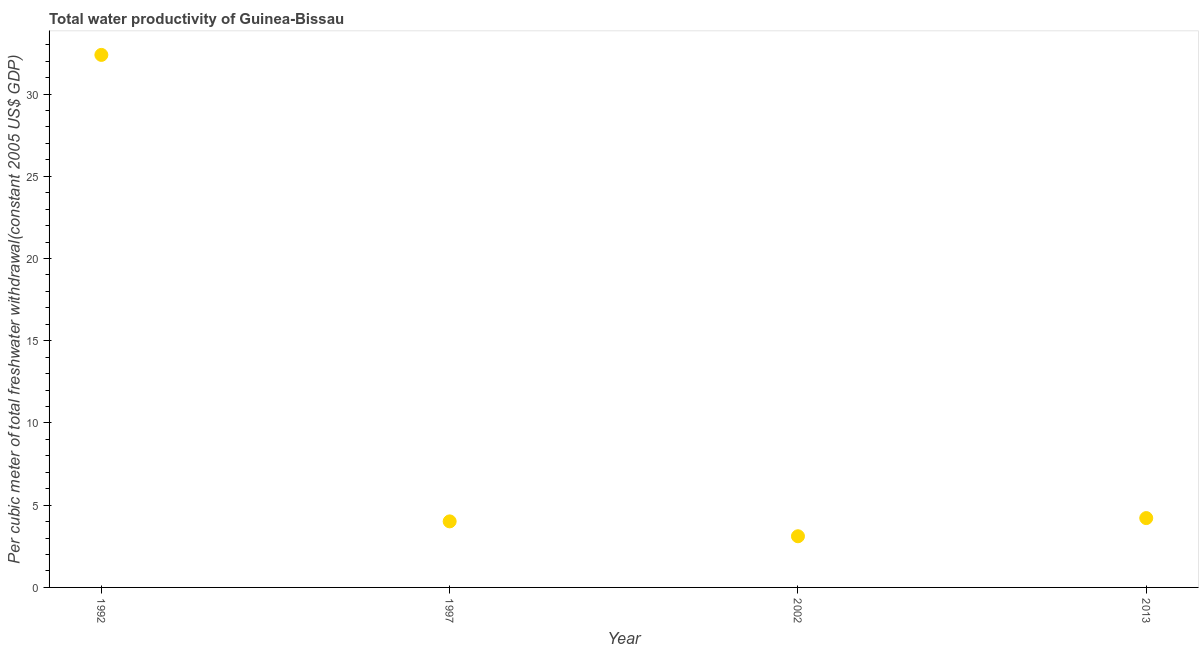What is the total water productivity in 2002?
Give a very brief answer. 3.11. Across all years, what is the maximum total water productivity?
Give a very brief answer. 32.38. Across all years, what is the minimum total water productivity?
Offer a very short reply. 3.11. In which year was the total water productivity minimum?
Give a very brief answer. 2002. What is the sum of the total water productivity?
Give a very brief answer. 43.73. What is the difference between the total water productivity in 2002 and 2013?
Keep it short and to the point. -1.1. What is the average total water productivity per year?
Your answer should be very brief. 10.93. What is the median total water productivity?
Make the answer very short. 4.12. Do a majority of the years between 1992 and 2002 (inclusive) have total water productivity greater than 9 US$?
Provide a succinct answer. No. What is the ratio of the total water productivity in 1997 to that in 2013?
Offer a very short reply. 0.95. Is the total water productivity in 2002 less than that in 2013?
Your response must be concise. Yes. What is the difference between the highest and the second highest total water productivity?
Your answer should be very brief. 28.17. What is the difference between the highest and the lowest total water productivity?
Keep it short and to the point. 29.27. Are the values on the major ticks of Y-axis written in scientific E-notation?
Make the answer very short. No. Does the graph contain any zero values?
Your response must be concise. No. What is the title of the graph?
Ensure brevity in your answer.  Total water productivity of Guinea-Bissau. What is the label or title of the X-axis?
Keep it short and to the point. Year. What is the label or title of the Y-axis?
Offer a very short reply. Per cubic meter of total freshwater withdrawal(constant 2005 US$ GDP). What is the Per cubic meter of total freshwater withdrawal(constant 2005 US$ GDP) in 1992?
Your answer should be very brief. 32.38. What is the Per cubic meter of total freshwater withdrawal(constant 2005 US$ GDP) in 1997?
Keep it short and to the point. 4.02. What is the Per cubic meter of total freshwater withdrawal(constant 2005 US$ GDP) in 2002?
Offer a terse response. 3.11. What is the Per cubic meter of total freshwater withdrawal(constant 2005 US$ GDP) in 2013?
Your answer should be very brief. 4.22. What is the difference between the Per cubic meter of total freshwater withdrawal(constant 2005 US$ GDP) in 1992 and 1997?
Ensure brevity in your answer.  28.37. What is the difference between the Per cubic meter of total freshwater withdrawal(constant 2005 US$ GDP) in 1992 and 2002?
Ensure brevity in your answer.  29.27. What is the difference between the Per cubic meter of total freshwater withdrawal(constant 2005 US$ GDP) in 1992 and 2013?
Provide a succinct answer. 28.17. What is the difference between the Per cubic meter of total freshwater withdrawal(constant 2005 US$ GDP) in 1997 and 2002?
Keep it short and to the point. 0.9. What is the difference between the Per cubic meter of total freshwater withdrawal(constant 2005 US$ GDP) in 1997 and 2013?
Make the answer very short. -0.2. What is the difference between the Per cubic meter of total freshwater withdrawal(constant 2005 US$ GDP) in 2002 and 2013?
Ensure brevity in your answer.  -1.1. What is the ratio of the Per cubic meter of total freshwater withdrawal(constant 2005 US$ GDP) in 1992 to that in 1997?
Offer a very short reply. 8.06. What is the ratio of the Per cubic meter of total freshwater withdrawal(constant 2005 US$ GDP) in 1992 to that in 2002?
Offer a very short reply. 10.41. What is the ratio of the Per cubic meter of total freshwater withdrawal(constant 2005 US$ GDP) in 1992 to that in 2013?
Ensure brevity in your answer.  7.68. What is the ratio of the Per cubic meter of total freshwater withdrawal(constant 2005 US$ GDP) in 1997 to that in 2002?
Keep it short and to the point. 1.29. What is the ratio of the Per cubic meter of total freshwater withdrawal(constant 2005 US$ GDP) in 1997 to that in 2013?
Ensure brevity in your answer.  0.95. What is the ratio of the Per cubic meter of total freshwater withdrawal(constant 2005 US$ GDP) in 2002 to that in 2013?
Keep it short and to the point. 0.74. 